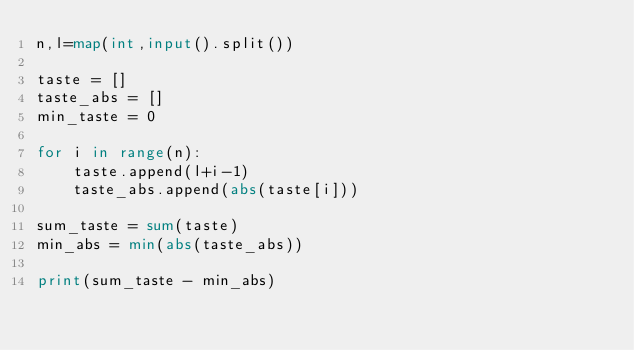<code> <loc_0><loc_0><loc_500><loc_500><_Python_>n,l=map(int,input().split())

taste = []
taste_abs = []
min_taste = 0

for i in range(n):
    taste.append(l+i-1)
    taste_abs.append(abs(taste[i]))

sum_taste = sum(taste)
min_abs = min(abs(taste_abs))

print(sum_taste - min_abs)</code> 